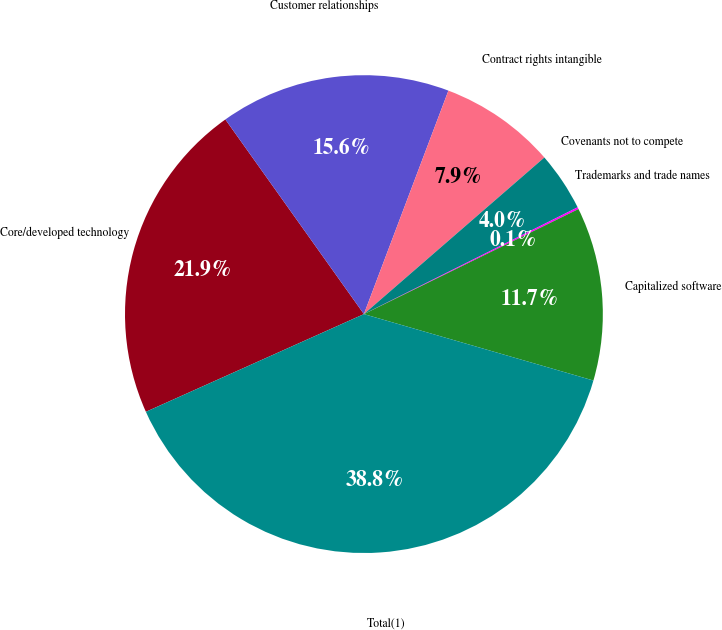Convert chart to OTSL. <chart><loc_0><loc_0><loc_500><loc_500><pie_chart><fcel>Core/developed technology<fcel>Customer relationships<fcel>Contract rights intangible<fcel>Covenants not to compete<fcel>Trademarks and trade names<fcel>Capitalized software<fcel>Total(1)<nl><fcel>21.86%<fcel>15.6%<fcel>7.87%<fcel>4.0%<fcel>0.13%<fcel>11.73%<fcel>38.81%<nl></chart> 